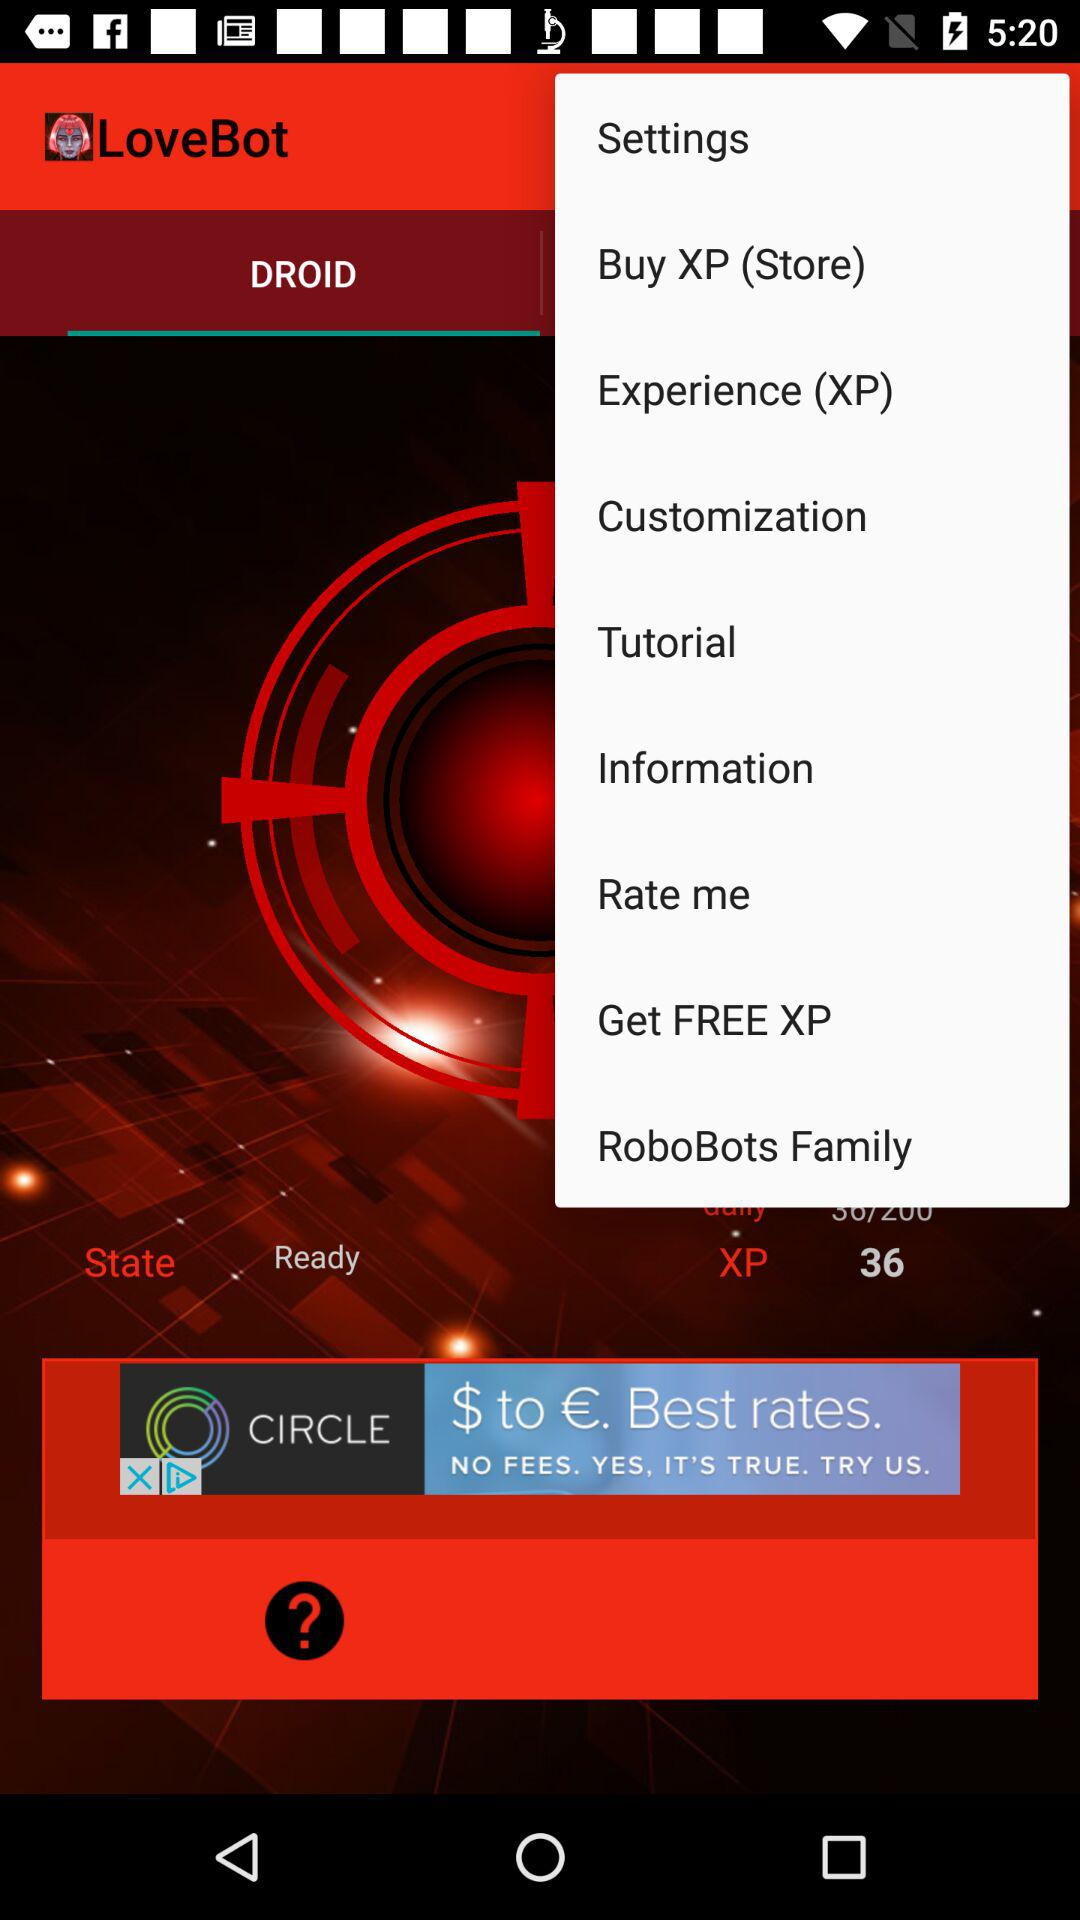How much XP do I need to level up?
Answer the question using a single word or phrase. 36 